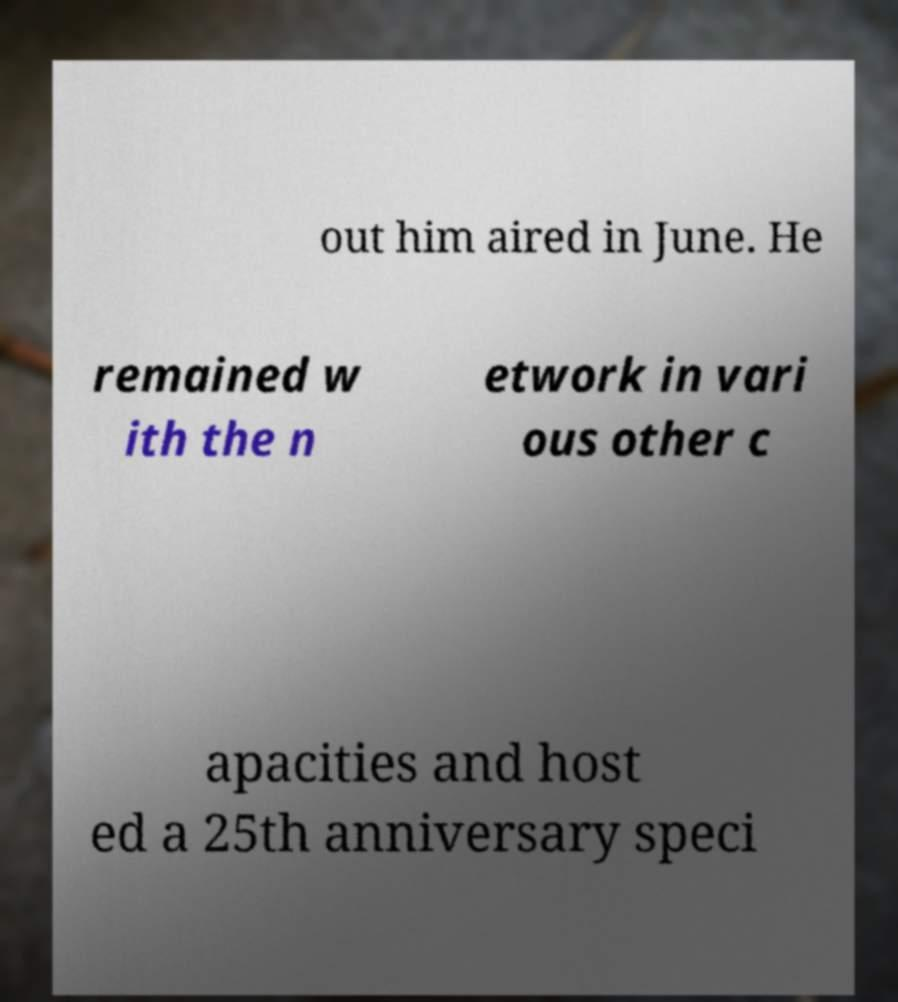Could you assist in decoding the text presented in this image and type it out clearly? out him aired in June. He remained w ith the n etwork in vari ous other c apacities and host ed a 25th anniversary speci 